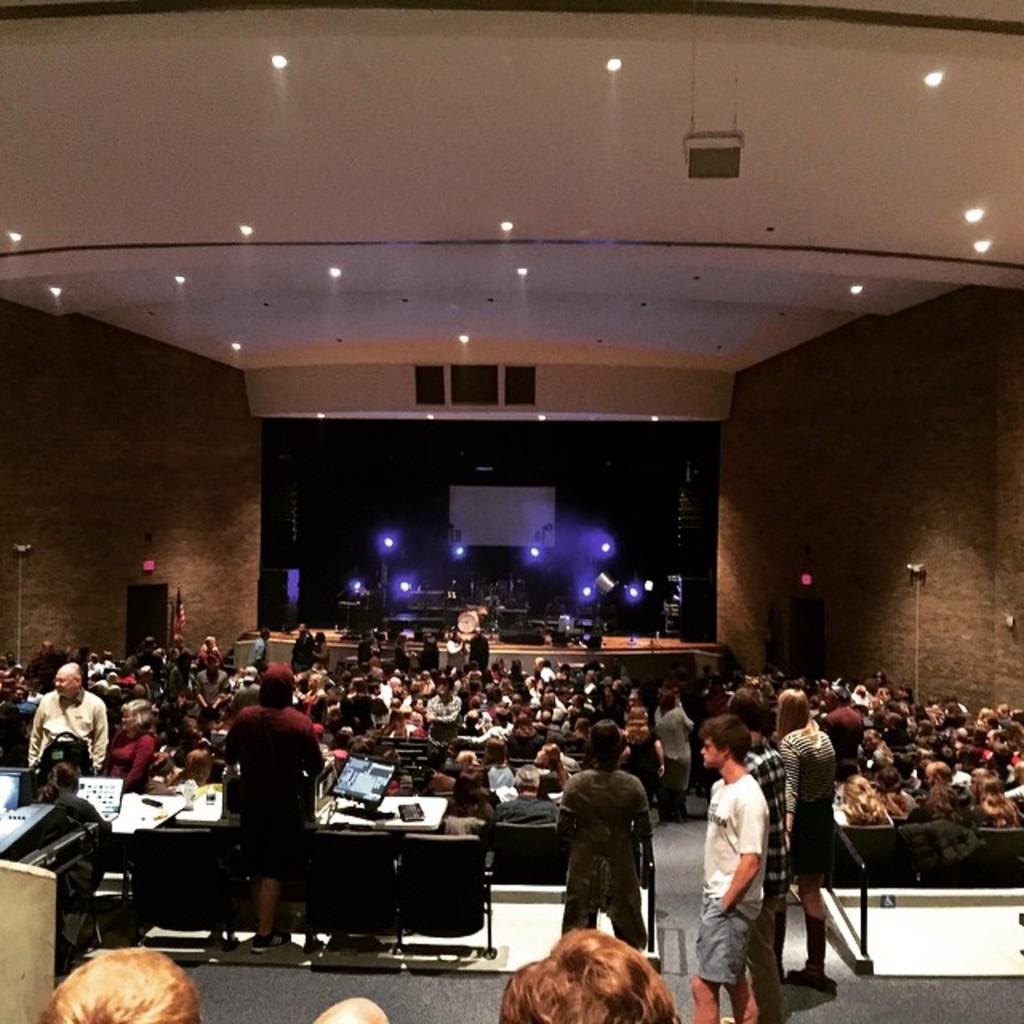Please provide a concise description of this image. In this image I can see number of persons are sitting on chairs which are black in color and few persons standing. I can see few monitors and in the background I can see the stage and on the stage I can see few lights and a screen. I can see the ceiling and few lights to the ceiling. 